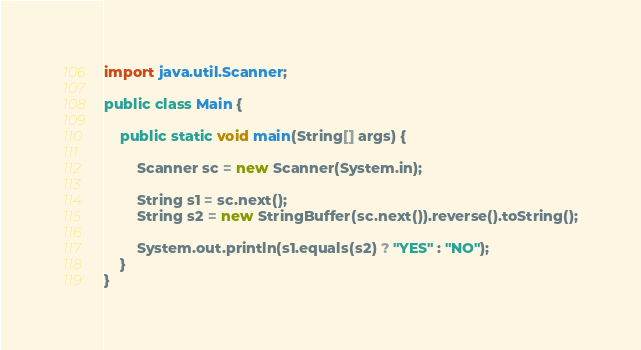<code> <loc_0><loc_0><loc_500><loc_500><_Java_>import java.util.Scanner;

public class Main {

	public static void main(String[] args) {

		Scanner sc = new Scanner(System.in);

		String s1 = sc.next();
		String s2 = new StringBuffer(sc.next()).reverse().toString();

		System.out.println(s1.equals(s2) ? "YES" : "NO");
	}
}</code> 